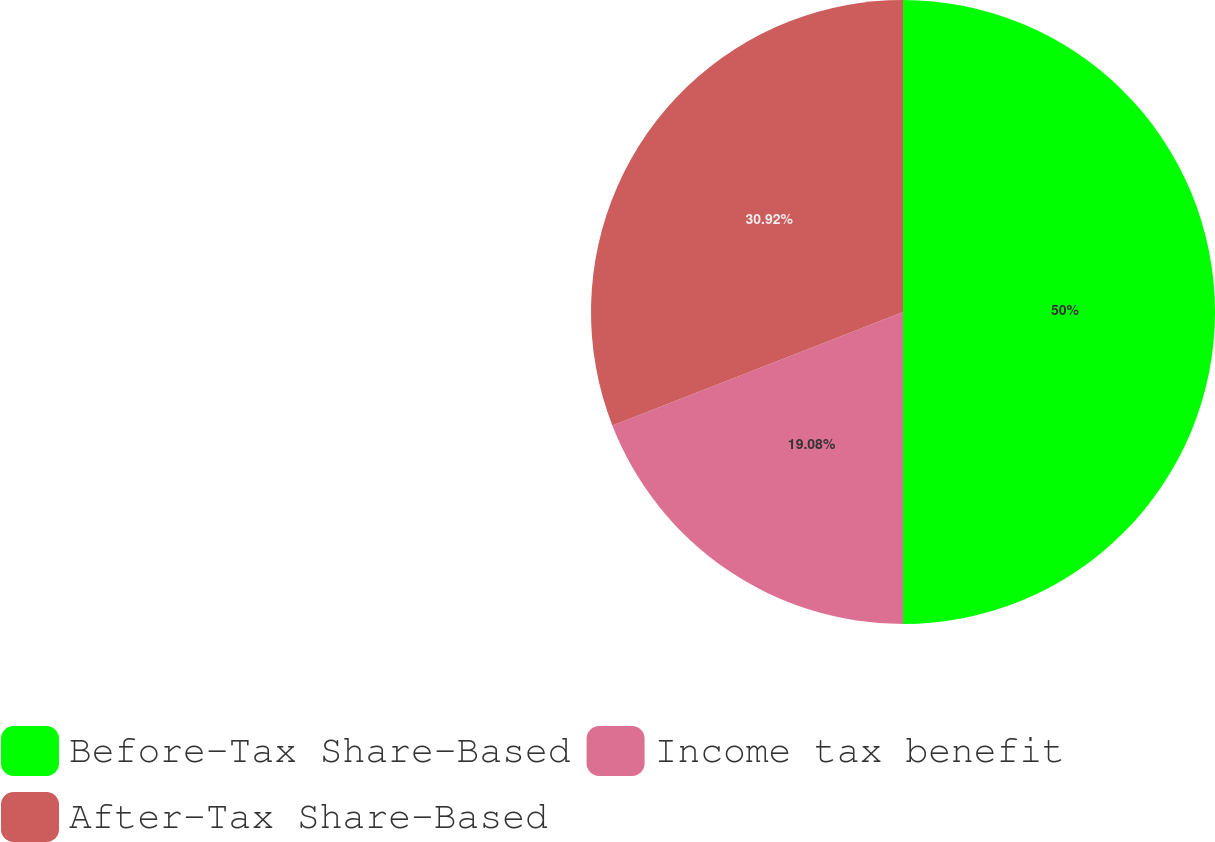Convert chart. <chart><loc_0><loc_0><loc_500><loc_500><pie_chart><fcel>Before-Tax Share-Based<fcel>Income tax benefit<fcel>After-Tax Share-Based<nl><fcel>50.0%<fcel>19.08%<fcel>30.92%<nl></chart> 